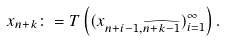<formula> <loc_0><loc_0><loc_500><loc_500>x _ { n + k } \colon = T \left ( ( x _ { n + i - 1 , \widehat { n + k - 1 } } ) _ { i = 1 } ^ { \infty } \right ) .</formula> 